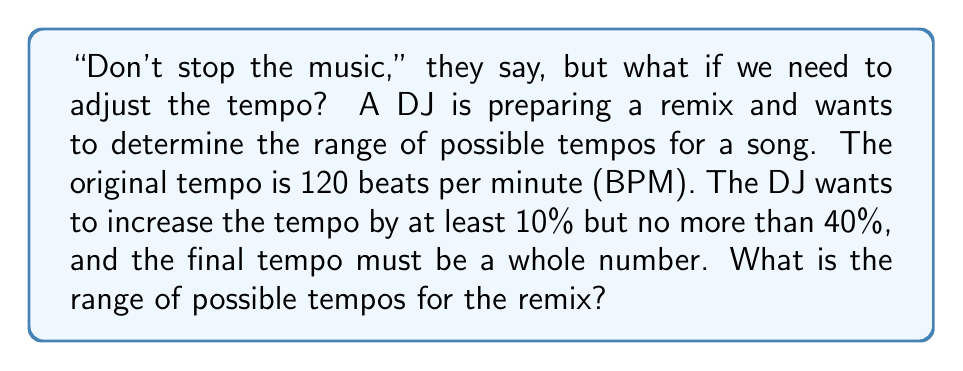Provide a solution to this math problem. Let's approach this step-by-step:

1) First, let's calculate the minimum and maximum tempos based on the given percentages:

   Minimum: $120 \times 1.10 = 132$ BPM
   Maximum: $120 \times 1.40 = 168$ BPM

2) Now, we need to consider that the final tempo must be a whole number. So, we need to round up the minimum and round down the maximum:

   Minimum (rounded up): $\lceil 132 \rceil = 132$ BPM
   Maximum (rounded down): $\lfloor 168 \rfloor = 168$ BPM

3) The range of possible tempos is therefore all whole numbers from 132 to 168, inclusive.

4) To express this as an inequality:

   $132 \leq x \leq 168$, where $x$ is a whole number

5) The number of possible tempos is:

   $168 - 132 + 1 = 37$

   We add 1 because both 132 and 168 are included in the range.
Answer: $132 \leq x \leq 168$, $x \in \mathbb{Z}$ 